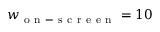<formula> <loc_0><loc_0><loc_500><loc_500>w _ { o n - s c r e e n } = 1 0</formula> 